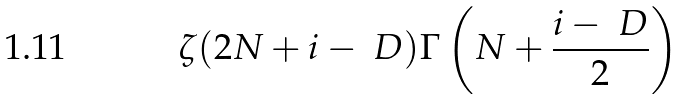<formula> <loc_0><loc_0><loc_500><loc_500>\zeta ( 2 N + i - \ D ) \Gamma \left ( N + \frac { i - \ D } { 2 } \right )</formula> 